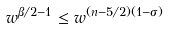Convert formula to latex. <formula><loc_0><loc_0><loc_500><loc_500>w ^ { \beta / 2 - 1 } \leq w ^ { ( n - 5 / 2 ) ( 1 - \sigma ) }</formula> 